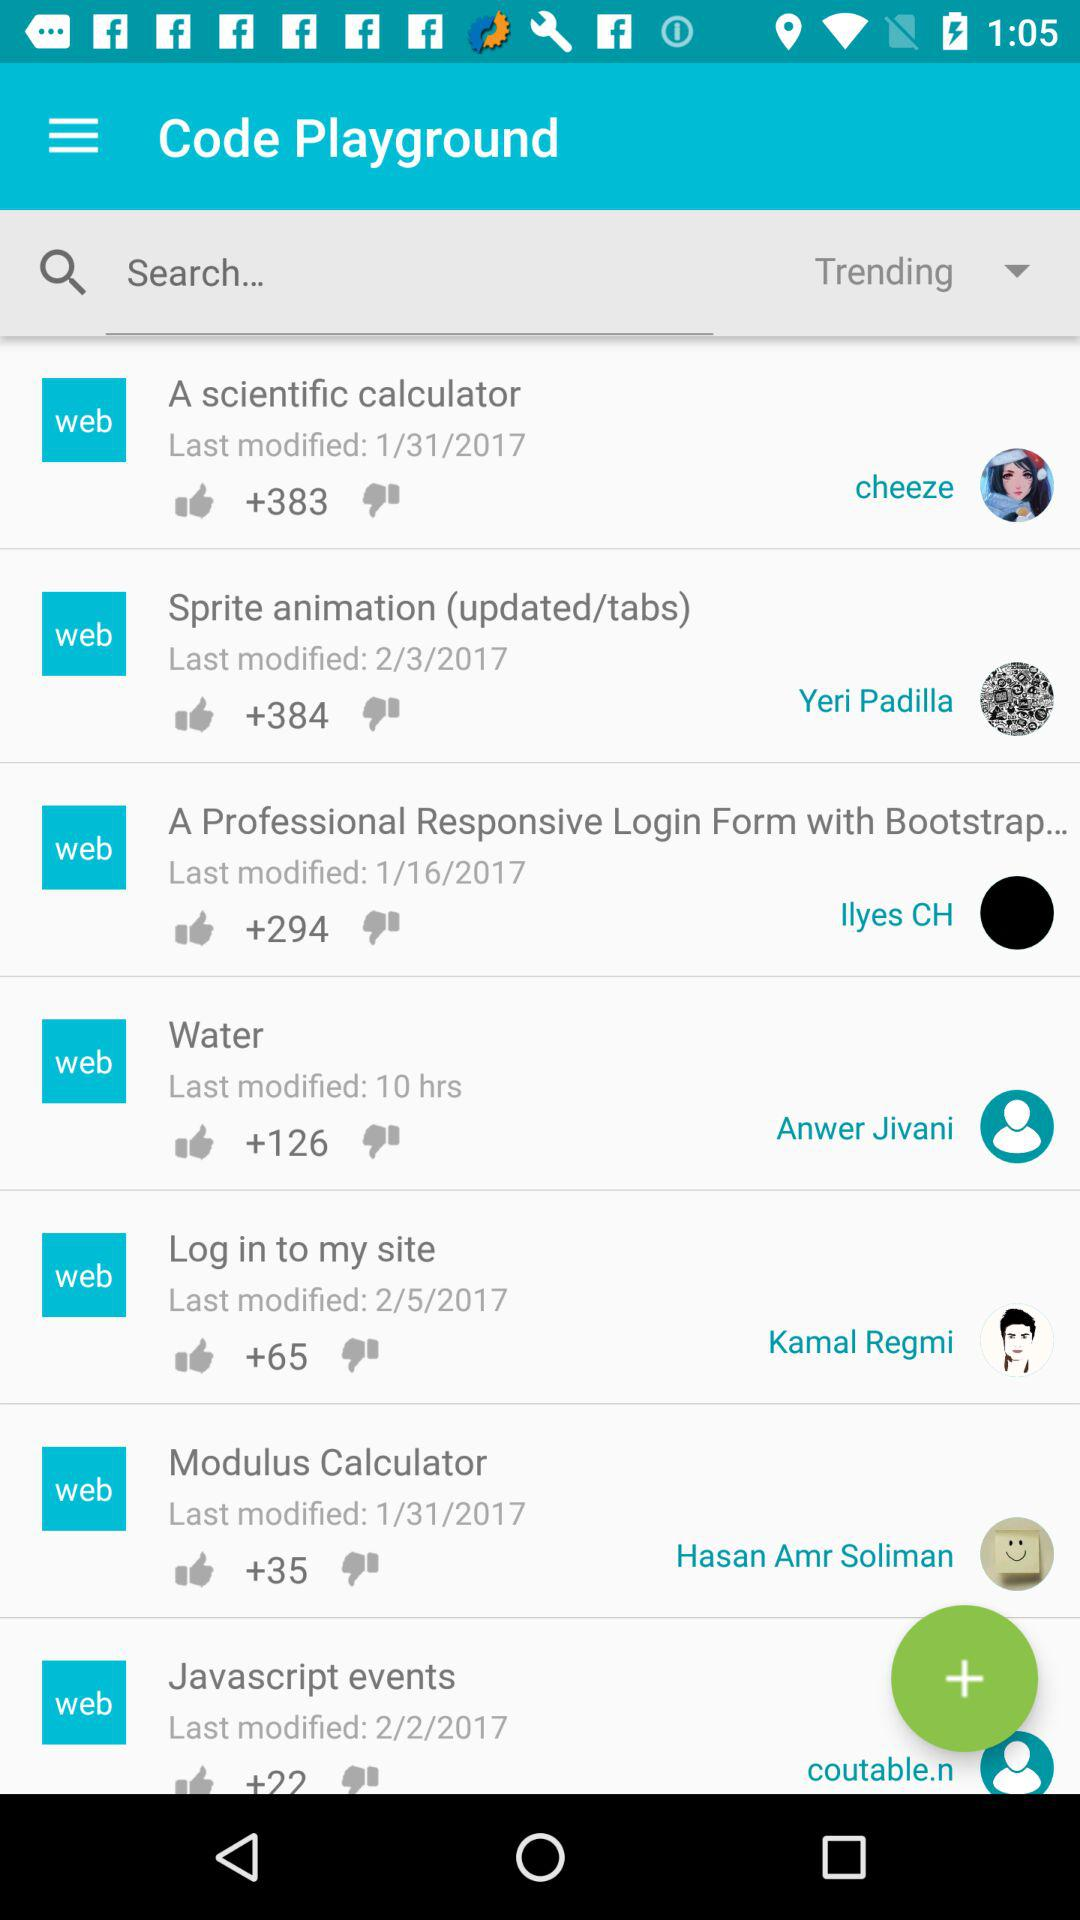What is the last modified date of water?
When the provided information is insufficient, respond with <no answer>. <no answer> 